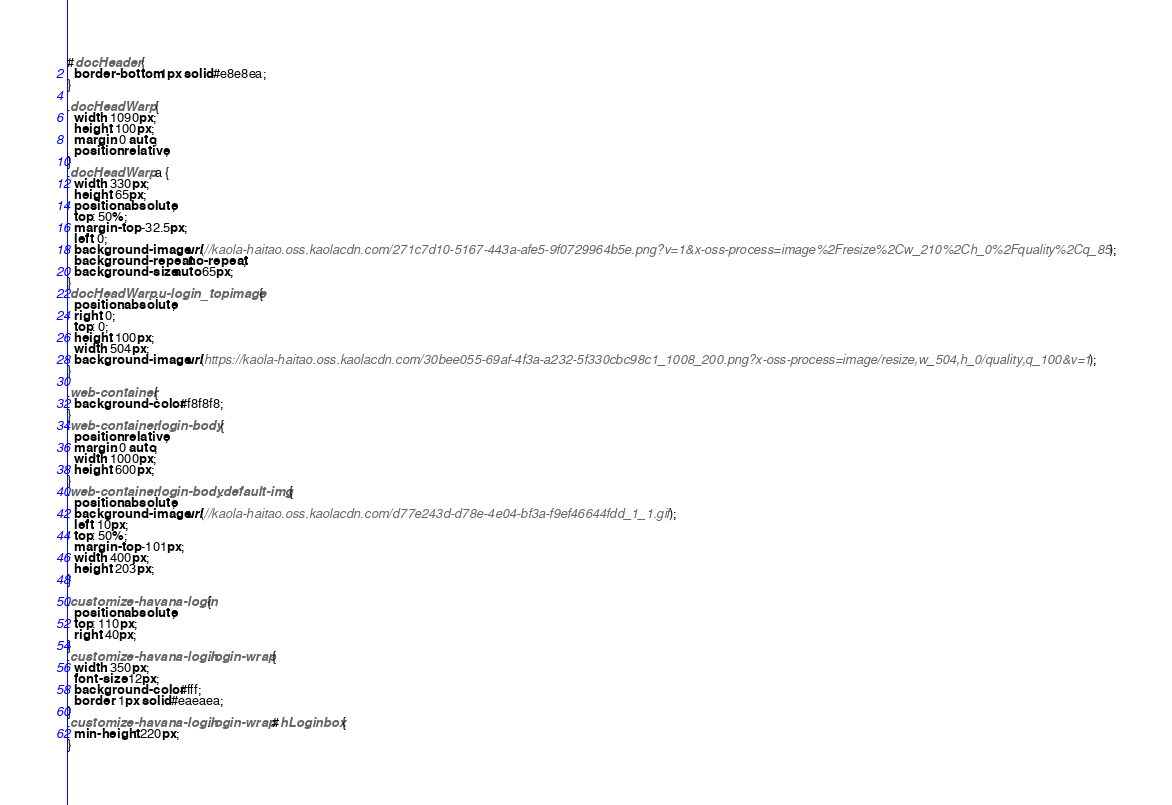Convert code to text. <code><loc_0><loc_0><loc_500><loc_500><_CSS_>#docHeader {
  border-bottom: 1px solid #e8e8ea;
}

.docHeadWarp {
  width: 1090px;
  height: 100px;
  margin: 0 auto;
  position: relative;
}
.docHeadWarp a {
  width: 330px;
  height: 65px;
  position: absolute;
  top: 50%;
  margin-top: -32.5px;
  left: 0;
  background-image: url(//kaola-haitao.oss.kaolacdn.com/271c7d10-5167-443a-afe5-9f0729964b5e.png?v=1&x-oss-process=image%2Fresize%2Cw_210%2Ch_0%2Fquality%2Cq_85);
  background-repeat: no-repeat;
  background-size: auto 65px;
}
.docHeadWarp .u-login_topimage {
  position: absolute;
  right: 0;
  top: 0;
  height: 100px;
  width: 504px;
  background-image: url(https://kaola-haitao.oss.kaolacdn.com/30bee055-69af-4f3a-a232-5f330cbc98c1_1008_200.png?x-oss-process=image/resize,w_504,h_0/quality,q_100&v=1);
}

.web-container {
  background-color: #f8f8f8;
}
.web-container .login-body {
  position: relative;
  margin: 0 auto;
  width: 1000px;
  height: 600px;
}
.web-container .login-body .default-img {
  position: absolute;
  background-image: url(//kaola-haitao.oss.kaolacdn.com/d77e243d-d78e-4e04-bf3a-f9ef46644fdd_1_1.gif);
  left: 10px;
  top: 50%;
  margin-top: -101px;
  width: 400px;
  height: 203px;
}

.customize-havana-login {
  position: absolute;
  top: 110px;
  right: 40px;
}
.customize-havana-login .login-wrap {
  width: 350px;
  font-size: 12px;
  background-color: #fff;
  border: 1px solid #eaeaea;
}
.customize-havana-login .login-wrap #hLoginbox {
  min-height: 220px;
}</code> 